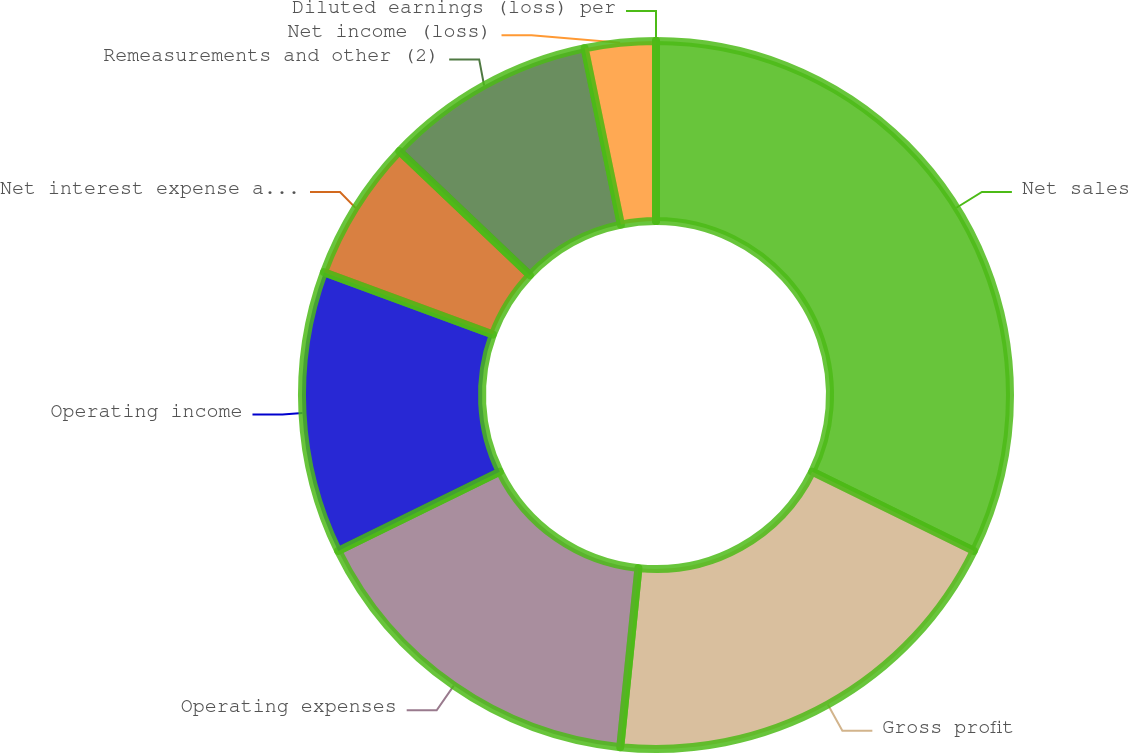Convert chart to OTSL. <chart><loc_0><loc_0><loc_500><loc_500><pie_chart><fcel>Net sales<fcel>Gross profit<fcel>Operating expenses<fcel>Operating income<fcel>Net interest expense and other<fcel>Remeasurements and other (2)<fcel>Net income (loss)<fcel>Diluted earnings (loss) per<nl><fcel>32.26%<fcel>19.35%<fcel>16.13%<fcel>12.9%<fcel>6.45%<fcel>9.68%<fcel>3.23%<fcel>0.0%<nl></chart> 